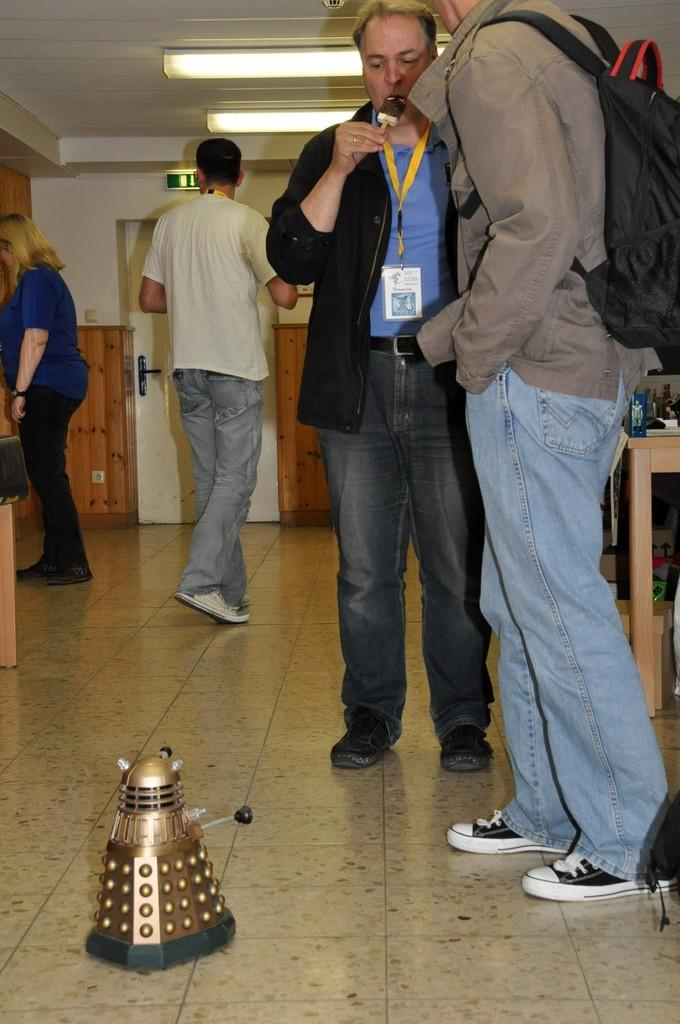How many people are present in the image? There are four people in the image. What can be seen on the floor in the image? There is a toy on the floor. What is the man in the image carrying? The man is carrying a bag. What can be seen in the background of the image? There are lights, a wall, a table, and some objects visible in the background. How many boats are visible in the image? There are no boats present in the image. What type of bead is being used by the people in the image? There is no bead present in the image. 